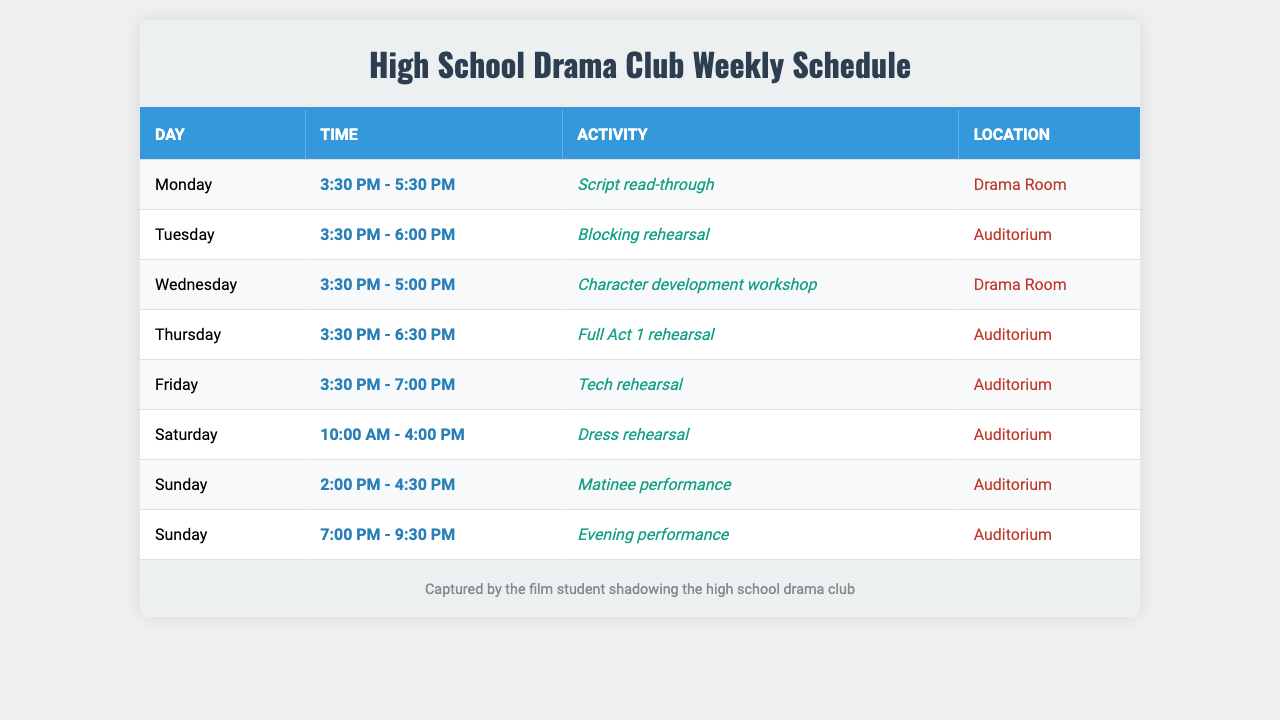What activity takes place on Tuesday? The schedule shows that on Tuesday, from 3:30 PM to 6:00 PM, there is a "Blocking rehearsal" in the "Auditorium."
Answer: Blocking rehearsal How many rehearsals are scheduled for this week? Counting the activities in the schedule, there are 6 rehearsals planned: Script read-through on Monday, Blocking rehearsal on Tuesday, Character development workshop on Wednesday, Full Act 1 rehearsal on Thursday, Tech rehearsal on Friday, and Dress rehearsal on Saturday.
Answer: 6 Is there a performance scheduled on Sunday? Yes, the schedule lists two performances on Sunday: a "Matinee performance" from 2:00 PM to 4:30 PM and an "Evening performance" from 7:00 PM to 9:30 PM.
Answer: Yes Which day has the longest rehearsal duration? By comparing the time durations of all activities, Saturday's Dress rehearsal spans from 10:00 AM to 4:00 PM, totaling 6 hours, which is longer than any other rehearsal days.
Answer: Saturday What is the total duration of rehearsals from Monday to Friday? The total durations for Monday (2 hours), Tuesday (2.5 hours), Wednesday (1.5 hours), Thursday (3 hours), and Friday (3.5 hours) add up to 12.5 hours for the week from Monday to Friday.
Answer: 12.5 hours Are all activities held in the same location? No, the schedule indicates that activities are held in two locations: the "Drama Room" for Script read-through and Character development workshop, and the "Auditorium" for all other activities.
Answer: No Which day features the character development workshop? The Character development workshop is scheduled for Wednesday from 3:30 PM to 5:00 PM in the Drama Room.
Answer: Wednesday What time does the tech rehearsal start? The tech rehearsal on Friday begins at 3:30 PM.
Answer: 3:30 PM Is there a rehearsal that overlaps with the evening performance? Yes, there is an overlap because the evening performance starts at 7:00 PM, which means it overlaps with the tech rehearsal, that ends at 7:00 PM.
Answer: Yes What activity occurs immediately after the blocking rehearsal? The very next activity after the Blocking rehearsal on Tuesday (ends at 6:00 PM) is the Character development workshop on Wednesday at 3:30 PM.
Answer: Character development workshop 